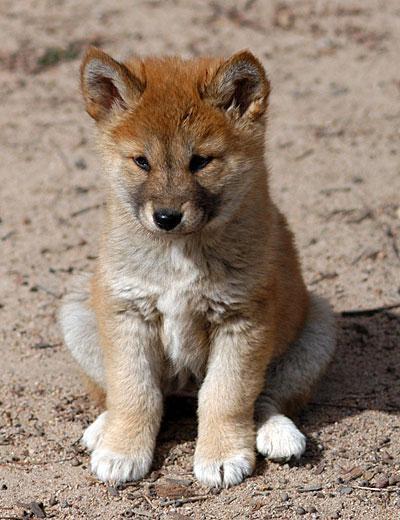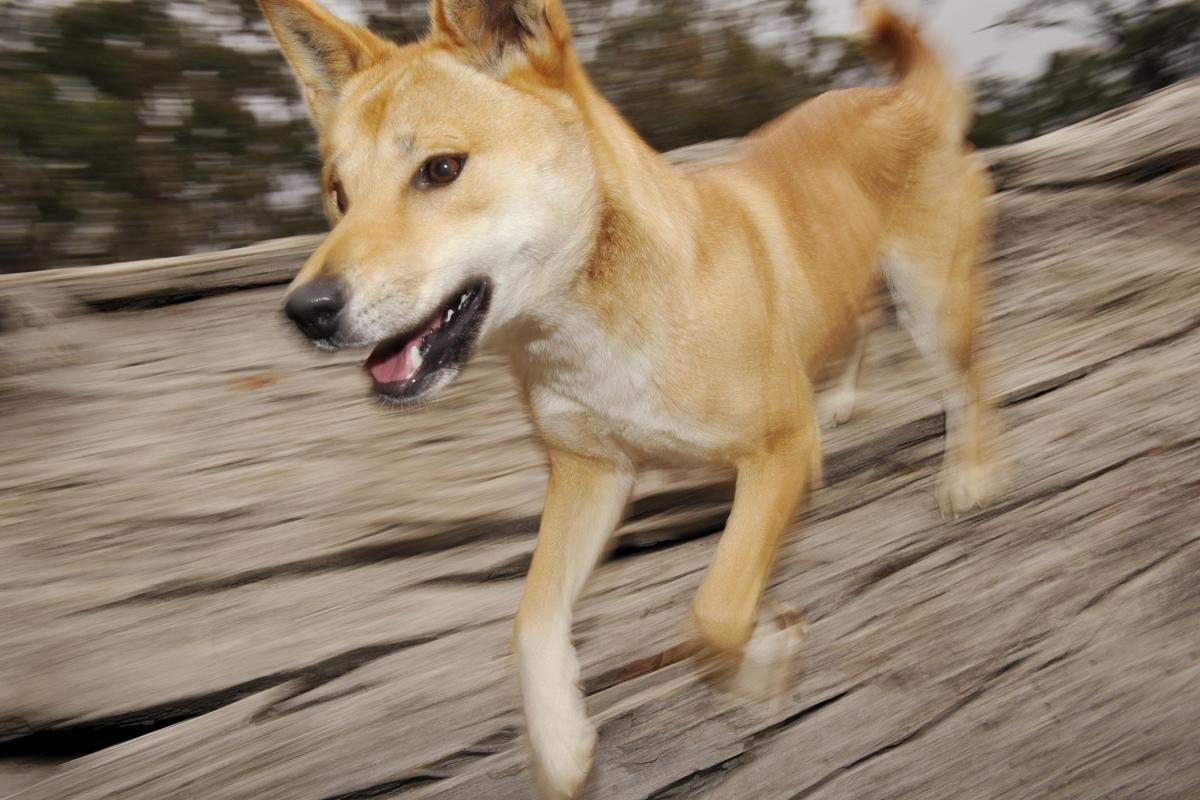The first image is the image on the left, the second image is the image on the right. Assess this claim about the two images: "The dog on the right image is running.". Correct or not? Answer yes or no. Yes. 